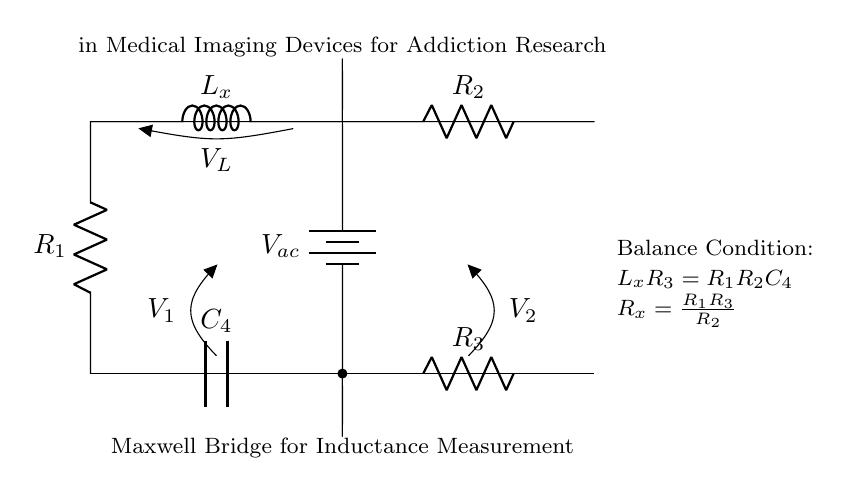What is the value of the inductance being measured? The specific value of the inductance is not directly provided in the circuit diagram. It's represented as \( L_x \) in the circuit, indicating the inductance to be measured.
Answer: L_x What is the role of the capacitor in this circuit? The capacitor labeled \( C_4 \) is part of the bridge circuit used to help balance the circuit and determine the unknown inductance \( L_x \) through adjustments involving the resistors.
Answer: Balance How can the balance condition be expressed? The balance condition for the Maxwell bridge indicates that the product of the inductance \( L_x \) and resistance \( R_3 \) is equal to the product of resistances \( R_1 \), \( R_2 \) and capacitance \( C_4 \), written as \( L_x R_3 = R_1 R_2 C_4 \).
Answer: L_x R_3 = R_1 R_2 C_4 What is the purpose of the voltage labeled \( V_{ac} \)? The voltage \( V_{ac} \) represents an alternating current voltage supply that energizes the bridge to facilitate the measurement of the inductance \( L_x \).
Answer: Alternating current supply What is the relationship of \( R_x \) in the context of the circuit? The relationship \( R_x = \frac{R_1 R_3}{R_2} \) indicates how the unknown resistance \( R_x \) can be calculated using the known resistances \( R_1 \), \( R_2 \), and \( R_3 \) to achieve a balance in the circuit.
Answer: R_x = R_1 R_3 / R_2 What type of circuit is represented by this diagram? This diagram represents a Maxwell Bridge circuit, which is specifically designed for measuring inductance.
Answer: Maxwell Bridge What types of components are primarily used in this circuit? The circuit primarily utilizes resistors, an inductor, a capacitor, and an alternating current voltage source.
Answer: Resistors, inductor, capacitor, voltage source 